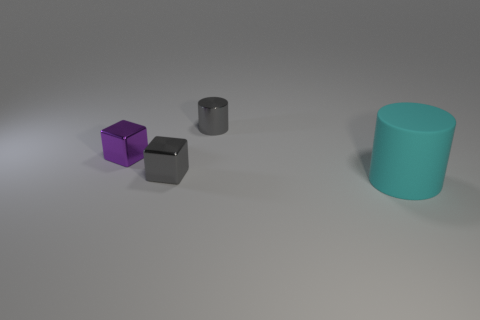Add 1 big gray spheres. How many objects exist? 5 Add 2 metallic cubes. How many metallic cubes exist? 4 Subtract 0 blue blocks. How many objects are left? 4 Subtract all large brown metallic blocks. Subtract all purple metal cubes. How many objects are left? 3 Add 2 gray shiny blocks. How many gray shiny blocks are left? 3 